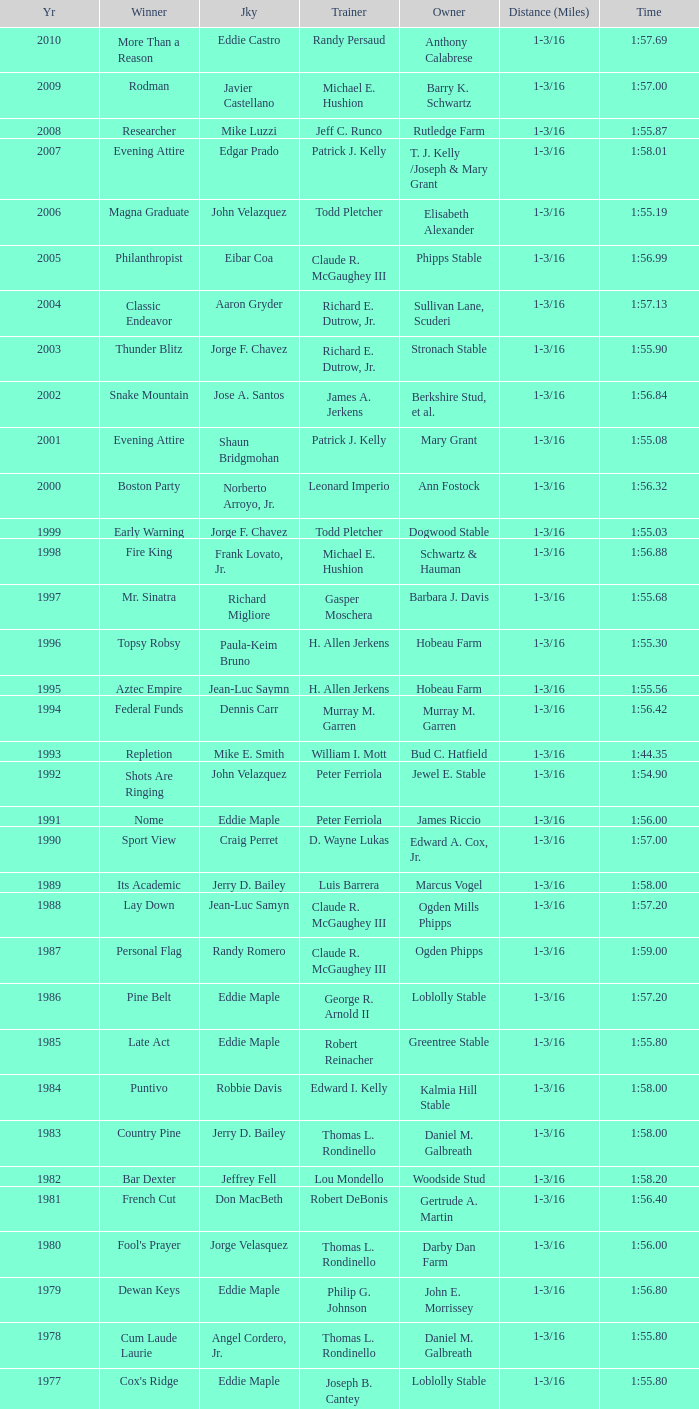Could you help me parse every detail presented in this table? {'header': ['Yr', 'Winner', 'Jky', 'Trainer', 'Owner', 'Distance (Miles)', 'Time'], 'rows': [['2010', 'More Than a Reason', 'Eddie Castro', 'Randy Persaud', 'Anthony Calabrese', '1-3/16', '1:57.69'], ['2009', 'Rodman', 'Javier Castellano', 'Michael E. Hushion', 'Barry K. Schwartz', '1-3/16', '1:57.00'], ['2008', 'Researcher', 'Mike Luzzi', 'Jeff C. Runco', 'Rutledge Farm', '1-3/16', '1:55.87'], ['2007', 'Evening Attire', 'Edgar Prado', 'Patrick J. Kelly', 'T. J. Kelly /Joseph & Mary Grant', '1-3/16', '1:58.01'], ['2006', 'Magna Graduate', 'John Velazquez', 'Todd Pletcher', 'Elisabeth Alexander', '1-3/16', '1:55.19'], ['2005', 'Philanthropist', 'Eibar Coa', 'Claude R. McGaughey III', 'Phipps Stable', '1-3/16', '1:56.99'], ['2004', 'Classic Endeavor', 'Aaron Gryder', 'Richard E. Dutrow, Jr.', 'Sullivan Lane, Scuderi', '1-3/16', '1:57.13'], ['2003', 'Thunder Blitz', 'Jorge F. Chavez', 'Richard E. Dutrow, Jr.', 'Stronach Stable', '1-3/16', '1:55.90'], ['2002', 'Snake Mountain', 'Jose A. Santos', 'James A. Jerkens', 'Berkshire Stud, et al.', '1-3/16', '1:56.84'], ['2001', 'Evening Attire', 'Shaun Bridgmohan', 'Patrick J. Kelly', 'Mary Grant', '1-3/16', '1:55.08'], ['2000', 'Boston Party', 'Norberto Arroyo, Jr.', 'Leonard Imperio', 'Ann Fostock', '1-3/16', '1:56.32'], ['1999', 'Early Warning', 'Jorge F. Chavez', 'Todd Pletcher', 'Dogwood Stable', '1-3/16', '1:55.03'], ['1998', 'Fire King', 'Frank Lovato, Jr.', 'Michael E. Hushion', 'Schwartz & Hauman', '1-3/16', '1:56.88'], ['1997', 'Mr. Sinatra', 'Richard Migliore', 'Gasper Moschera', 'Barbara J. Davis', '1-3/16', '1:55.68'], ['1996', 'Topsy Robsy', 'Paula-Keim Bruno', 'H. Allen Jerkens', 'Hobeau Farm', '1-3/16', '1:55.30'], ['1995', 'Aztec Empire', 'Jean-Luc Saymn', 'H. Allen Jerkens', 'Hobeau Farm', '1-3/16', '1:55.56'], ['1994', 'Federal Funds', 'Dennis Carr', 'Murray M. Garren', 'Murray M. Garren', '1-3/16', '1:56.42'], ['1993', 'Repletion', 'Mike E. Smith', 'William I. Mott', 'Bud C. Hatfield', '1-3/16', '1:44.35'], ['1992', 'Shots Are Ringing', 'John Velazquez', 'Peter Ferriola', 'Jewel E. Stable', '1-3/16', '1:54.90'], ['1991', 'Nome', 'Eddie Maple', 'Peter Ferriola', 'James Riccio', '1-3/16', '1:56.00'], ['1990', 'Sport View', 'Craig Perret', 'D. Wayne Lukas', 'Edward A. Cox, Jr.', '1-3/16', '1:57.00'], ['1989', 'Its Academic', 'Jerry D. Bailey', 'Luis Barrera', 'Marcus Vogel', '1-3/16', '1:58.00'], ['1988', 'Lay Down', 'Jean-Luc Samyn', 'Claude R. McGaughey III', 'Ogden Mills Phipps', '1-3/16', '1:57.20'], ['1987', 'Personal Flag', 'Randy Romero', 'Claude R. McGaughey III', 'Ogden Phipps', '1-3/16', '1:59.00'], ['1986', 'Pine Belt', 'Eddie Maple', 'George R. Arnold II', 'Loblolly Stable', '1-3/16', '1:57.20'], ['1985', 'Late Act', 'Eddie Maple', 'Robert Reinacher', 'Greentree Stable', '1-3/16', '1:55.80'], ['1984', 'Puntivo', 'Robbie Davis', 'Edward I. Kelly', 'Kalmia Hill Stable', '1-3/16', '1:58.00'], ['1983', 'Country Pine', 'Jerry D. Bailey', 'Thomas L. Rondinello', 'Daniel M. Galbreath', '1-3/16', '1:58.00'], ['1982', 'Bar Dexter', 'Jeffrey Fell', 'Lou Mondello', 'Woodside Stud', '1-3/16', '1:58.20'], ['1981', 'French Cut', 'Don MacBeth', 'Robert DeBonis', 'Gertrude A. Martin', '1-3/16', '1:56.40'], ['1980', "Fool's Prayer", 'Jorge Velasquez', 'Thomas L. Rondinello', 'Darby Dan Farm', '1-3/16', '1:56.00'], ['1979', 'Dewan Keys', 'Eddie Maple', 'Philip G. Johnson', 'John E. Morrissey', '1-3/16', '1:56.80'], ['1978', 'Cum Laude Laurie', 'Angel Cordero, Jr.', 'Thomas L. Rondinello', 'Daniel M. Galbreath', '1-3/16', '1:55.80'], ['1977', "Cox's Ridge", 'Eddie Maple', 'Joseph B. Cantey', 'Loblolly Stable', '1-3/16', '1:55.80'], ['1976', "It's Freezing", 'Jacinto Vasquez', 'Anthony Basile', 'Bwamazon Farm', '1-3/16', '1:56.60'], ['1975', 'Hail The Pirates', 'Ron Turcotte', 'Thomas L. Rondinello', 'Daniel M. Galbreath', '1-3/16', '1:55.60'], ['1974', 'Free Hand', 'Jose Amy', 'Pancho Martin', 'Sigmund Sommer', '1-3/16', '1:55.00'], ['1973', 'True Knight', 'Angel Cordero, Jr.', 'Thomas L. Rondinello', 'Darby Dan Farm', '1-3/16', '1:55.00'], ['1972', 'Sunny And Mild', 'Michael Venezia', 'W. Preston King', 'Harry Rogosin', '1-3/16', '1:54.40'], ['1971', 'Red Reality', 'Jorge Velasquez', 'MacKenzie Miller', 'Cragwood Stables', '1-1/8', '1:49.60'], ['1970', 'Best Turn', 'Larry Adams', 'Reggie Cornell', 'Calumet Farm', '1-1/8', '1:50.00'], ['1969', 'Vif', 'Larry Adams', 'Clarence Meaux', 'Harvey Peltier', '1-1/8', '1:49.20'], ['1968', 'Irish Dude', 'Sandino Hernandez', 'Jack Bradley', 'Richard W. Taylor', '1-1/8', '1:49.60'], ['1967', 'Mr. Right', 'Heliodoro Gustines', 'Evan S. Jackson', 'Mrs. Peter Duchin', '1-1/8', '1:49.60'], ['1966', 'Amberoid', 'Walter Blum', 'Lucien Laurin', 'Reginald N. Webster', '1-1/8', '1:50.60'], ['1965', 'Prairie Schooner', 'Eddie Belmonte', 'James W. Smith', 'High Tide Stable', '1-1/8', '1:50.20'], ['1964', 'Third Martini', 'William Boland', 'H. Allen Jerkens', 'Hobeau Farm', '1-1/8', '1:50.60'], ['1963', 'Uppercut', 'Manuel Ycaza', 'Willard C. Freeman', 'William Harmonay', '1-1/8', '1:35.40'], ['1962', 'Grid Iron Hero', 'Manuel Ycaza', 'Laz Barrera', 'Emil Dolce', '1 mile', '1:34.00'], ['1961', 'Manassa Mauler', 'Braulio Baeza', 'Pancho Martin', 'Emil Dolce', '1 mile', '1:36.20'], ['1960', 'Cranberry Sauce', 'Heliodoro Gustines', 'not found', 'Elmendorf Farm', '1 mile', '1:36.20'], ['1959', 'Whitley', 'Eric Guerin', 'Max Hirsch', 'W. Arnold Hanger', '1 mile', '1:36.40'], ['1958', 'Oh Johnny', 'William Boland', 'Norman R. McLeod', 'Mrs. Wallace Gilroy', '1-1/16', '1:43.40'], ['1957', 'Bold Ruler', 'Eddie Arcaro', 'James E. Fitzsimmons', 'Wheatley Stable', '1-1/16', '1:42.80'], ['1956', 'Blessbull', 'Willie Lester', 'not found', 'Morris Sims', '1-1/16', '1:42.00'], ['1955', 'Fabulist', 'Ted Atkinson', 'William C. Winfrey', 'High Tide Stable', '1-1/16', '1:43.60'], ['1954', 'Find', 'Eric Guerin', 'William C. Winfrey', 'Alfred G. Vanderbilt II', '1-1/16', '1:44.00'], ['1953', 'Flaunt', 'S. Cole', 'Hubert W. Williams', 'Arnold Skjeveland', '1-1/16', '1:44.20'], ['1952', 'County Delight', 'Dave Gorman', 'James E. Ryan', 'Rokeby Stable', '1-1/16', '1:43.60'], ['1951', 'Sheilas Reward', 'Ovie Scurlock', 'Eugene Jacobs', 'Mrs. Louis Lazare', '1-1/16', '1:44.60'], ['1950', 'Three Rings', 'Hedley Woodhouse', 'Willie Knapp', 'Mrs. Evelyn L. Hopkins', '1-1/16', '1:44.60'], ['1949', 'Three Rings', 'Ted Atkinson', 'Willie Knapp', 'Mrs. Evelyn L. Hopkins', '1-1/16', '1:47.40'], ['1948', 'Knockdown', 'Ferrill Zufelt', 'Tom Smith', 'Maine Chance Farm', '1-1/16', '1:44.60'], ['1947', 'Gallorette', 'Job Dean Jessop', 'Edward A. Christmas', 'William L. Brann', '1-1/16', '1:45.40'], ['1946', 'Helioptic', 'Paul Miller', 'not found', 'William Goadby Loew', '1-1/16', '1:43.20'], ['1945', 'Olympic Zenith', 'Conn McCreary', 'Willie Booth', 'William G. Helis', '1-1/16', '1:45.60'], ['1944', 'First Fiddle', 'Johnny Longden', 'Edward Mulrenan', 'Mrs. Edward Mulrenan', '1-1/16', '1:44.20'], ['1943', 'The Rhymer', 'Conn McCreary', 'John M. Gaver, Sr.', 'Greentree Stable', '1-1/16', '1:45.00'], ['1942', 'Waller', 'Billie Thompson', 'A. G. Robertson', 'John C. Clark', '1-1/16', '1:44.00'], ['1941', 'Salford II', 'Don Meade', 'not found', 'Ralph B. Strassburger', '1-1/16', '1:44.20'], ['1940', 'He Did', 'Eddie Arcaro', 'J. Thomas Taylor', 'W. Arnold Hanger', '1-1/16', '1:43.20'], ['1939', 'Lovely Night', 'Johnny Longden', 'Henry McDaniel', 'Mrs. F. Ambrose Clark', '1 mile', '1:36.40'], ['1938', 'War Admiral', 'Charles Kurtsinger', 'George Conway', 'Glen Riddle Farm', '1 mile', '1:36.80'], ['1937', 'Snark', 'Johnny Longden', 'James E. Fitzsimmons', 'Wheatley Stable', '1 mile', '1:37.40'], ['1936', 'Good Gamble', 'Samuel Renick', 'Bud Stotler', 'Alfred G. Vanderbilt II', '1 mile', '1:37.20'], ['1935', 'King Saxon', 'Calvin Rainey', 'Charles Shaw', 'C. H. Knebelkamp', '1 mile', '1:37.20'], ['1934', 'Singing Wood', 'Robert Jones', 'James W. Healy', 'Liz Whitney', '1 mile', '1:38.60'], ['1933', 'Kerry Patch', 'Robert Wholey', 'Joseph A. Notter', 'Lee Rosenberg', '1 mile', '1:38.00'], ['1932', 'Halcyon', 'Hank Mills', 'T. J. Healey', 'C. V. Whitney', '1 mile', '1:38.00'], ['1931', 'Halcyon', 'G. Rose', 'T. J. Healey', 'C. V. Whitney', '1 mile', '1:38.40'], ['1930', 'Kildare', 'John Passero', 'Norman Tallman', 'Newtondale Stable', '1 mile', '1:38.60'], ['1929', 'Comstockery', 'Sidney Hebert', 'Thomas W. Murphy', 'Greentree Stable', '1 mile', '1:39.60'], ['1928', 'Kentucky II', 'George Schreiner', 'Max Hirsch', 'A. Charles Schwartz', '1 mile', '1:38.80'], ['1927', 'Light Carbine', 'James McCoy', 'M. J. Dunlevy', 'I. B. Humphreys', '1 mile', '1:36.80'], ['1926', 'Macaw', 'Linus McAtee', 'James G. Rowe, Sr.', 'Harry Payne Whitney', '1 mile', '1:37.00'], ['1925', 'Mad Play', 'Laverne Fator', 'Sam Hildreth', 'Rancocas Stable', '1 mile', '1:36.60'], ['1924', 'Mad Hatter', 'Earl Sande', 'Sam Hildreth', 'Rancocas Stable', '1 mile', '1:36.60'], ['1923', 'Zev', 'Earl Sande', 'Sam Hildreth', 'Rancocas Stable', '1 mile', '1:37.00'], ['1922', 'Grey Lag', 'Laverne Fator', 'Sam Hildreth', 'Rancocas Stable', '1 mile', '1:38.00'], ['1921', 'John P. Grier', 'Frank Keogh', 'James G. Rowe, Sr.', 'Harry Payne Whitney', '1 mile', '1:36.00'], ['1920', 'Cirrus', 'Lavelle Ensor', 'Sam Hildreth', 'Sam Hildreth', '1 mile', '1:38.00'], ['1919', 'Star Master', 'Merritt Buxton', 'Walter B. Jennings', 'A. Kingsley Macomber', '1 mile', '1:37.60'], ['1918', 'Roamer', 'Lawrence Lyke', 'A. J. Goldsborough', 'Andrew Miller', '1 mile', '1:36.60'], ['1917', 'Old Rosebud', 'Frank Robinson', 'Frank D. Weir', 'F. D. Weir & Hamilton C. Applegate', '1 mile', '1:37.60'], ['1916', 'Short Grass', 'Frank Keogh', 'not found', 'Emil Herz', '1 mile', '1:36.40'], ['1915', 'Roamer', 'James Butwell', 'A. J. Goldsborough', 'Andrew Miller', '1 mile', '1:39.20'], ['1914', 'Flying Fairy', 'Tommy Davies', 'J. Simon Healy', 'Edward B. Cassatt', '1 mile', '1:42.20'], ['1913', 'No Race', 'No Race', 'No Race', 'No Race', '1 mile', 'no race'], ['1912', 'No Race', 'No Race', 'No Race', 'No Race', '1 mile', 'no race'], ['1911', 'No Race', 'No Race', 'No Race', 'No Race', '1 mile', 'no race'], ['1910', 'Arasee', 'Buddy Glass', 'Andrew G. Blakely', 'Samuel Emery', '1 mile', '1:39.80'], ['1909', 'No Race', 'No Race', 'No Race', 'No Race', '1 mile', 'no race'], ['1908', 'Jack Atkin', 'Phil Musgrave', 'Herman R. Brandt', 'Barney Schreiber', '1 mile', '1:39.00'], ['1907', 'W. H. Carey', 'George Mountain', 'James Blute', 'Richard F. Carman', '1 mile', '1:40.00'], ['1906', "Ram's Horn", 'L. Perrine', 'W. S. "Jim" Williams', 'W. S. "Jim" Williams', '1 mile', '1:39.40'], ['1905', 'St. Valentine', 'William Crimmins', 'John Shields', 'Alexander Shields', '1 mile', '1:39.20'], ['1904', 'Rosetint', 'Thomas H. Burns', 'James Boden', 'John Boden', '1 mile', '1:39.20'], ['1903', 'Yellow Tail', 'Willie Shaw', 'H. E. Rowell', 'John Hackett', '1m 70yds', '1:45.20'], ['1902', 'Margravite', 'Otto Wonderly', 'not found', 'Charles Fleischmann Sons', '1m 70 yds', '1:46.00']]} What was the time for the winning horse Salford ii? 1:44.20. 